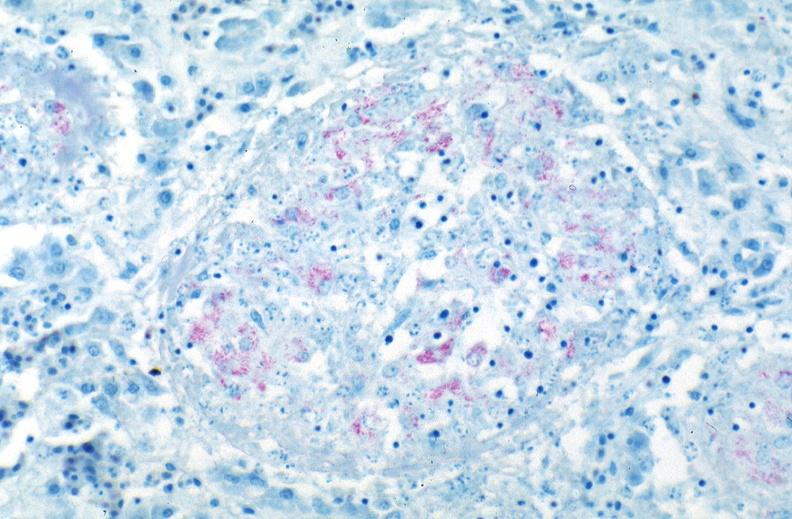does good example of muscle atrophy show lung, mycobacterium tuberculosis, acid fast?
Answer the question using a single word or phrase. No 